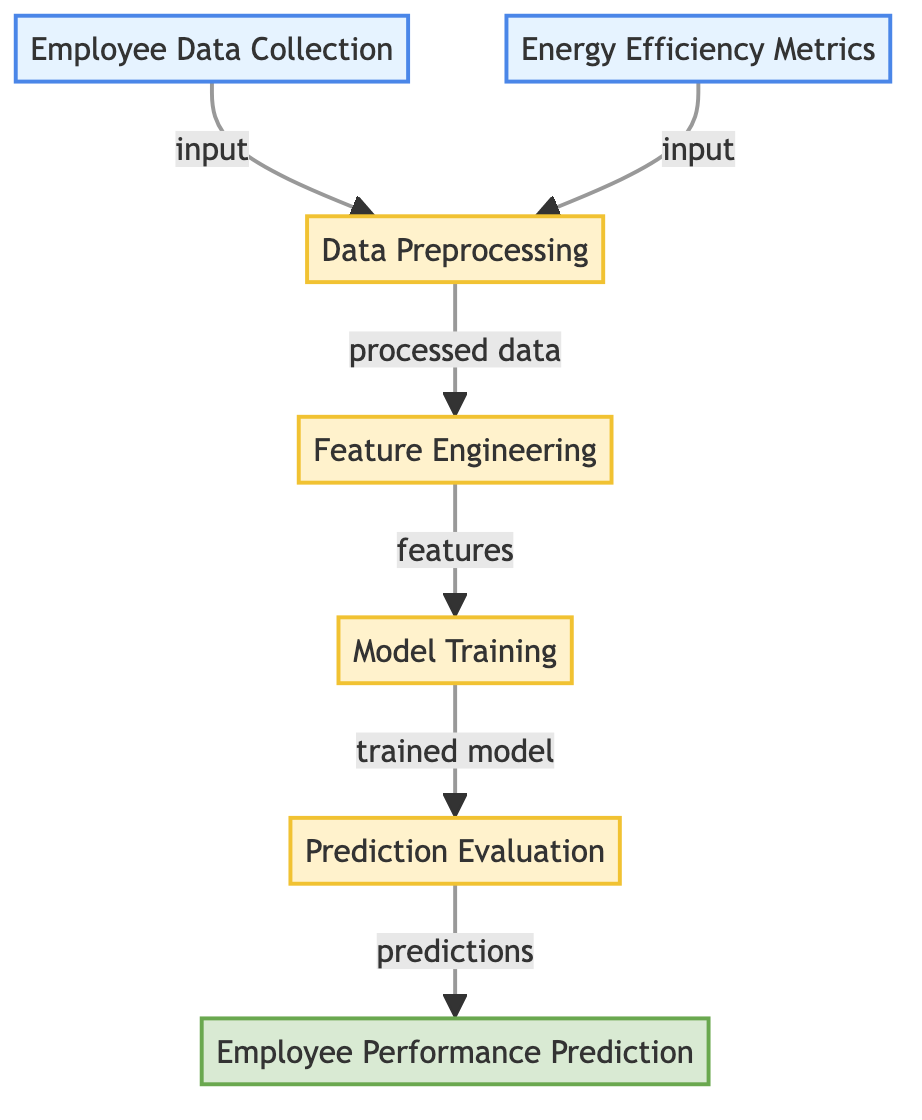What are the two primary data sources in this diagram? The diagram lists "Employee Data Collection" and "Energy Efficiency Metrics" as the two main data sources, connecting them to the data preprocessing node.
Answer: Employee Data Collection, Energy Efficiency Metrics How many processes are present in the workflow? The diagram shows five processes: data preprocessing, feature engineering, model training, and prediction evaluation. Counting these nodes gives a total of four distinct processes.
Answer: Four Which node connects directly to the "Employee Performance Prediction" output? The "Prediction Evaluation" node directly feeds into the "Employee Performance Prediction" output node, showing it as the last step in the process flow.
Answer: Prediction Evaluation What type of output is produced by the model training process? The model training process produces a "trained model" as its output, which is then utilized in the subsequent prediction evaluation step of the diagram.
Answer: Trained model What is the first step after collecting employee data and energy efficiency metrics? The first step after these input data sources is "Data Preprocessing," which indicates that data preparation occurs before feature engineering and model training.
Answer: Data Preprocessing What is the main objective of this machine learning workflow? The ultimate goal of the workflow is to generate "Employee Performance Prediction" based on the processed information, indicating a focus on assessing employee productivity influenced by energy efficiency metrics.
Answer: Employee Performance Prediction Which node follows closely after feature engineering in the process? The "Model Training" node follows directly after "Feature Engineering," indicating that model training is dependent on the features generated from the preprocessing stage.
Answer: Model Training What type of evaluation is conducted before making employee performance predictions? "Prediction Evaluation" is the type of evaluation conducted before arriving at employee performance predictions, ensuring the predictions are validated against expected outcomes.
Answer: Prediction Evaluation How are the edges in the diagram characterized visually? The edges in the diagram are characterized by a default stroke width of 2 pixels, with no fill, and a gray stroke color, which indicates connectivity between the nodes.
Answer: Stroke width of 2 pixels, gray stroke color 